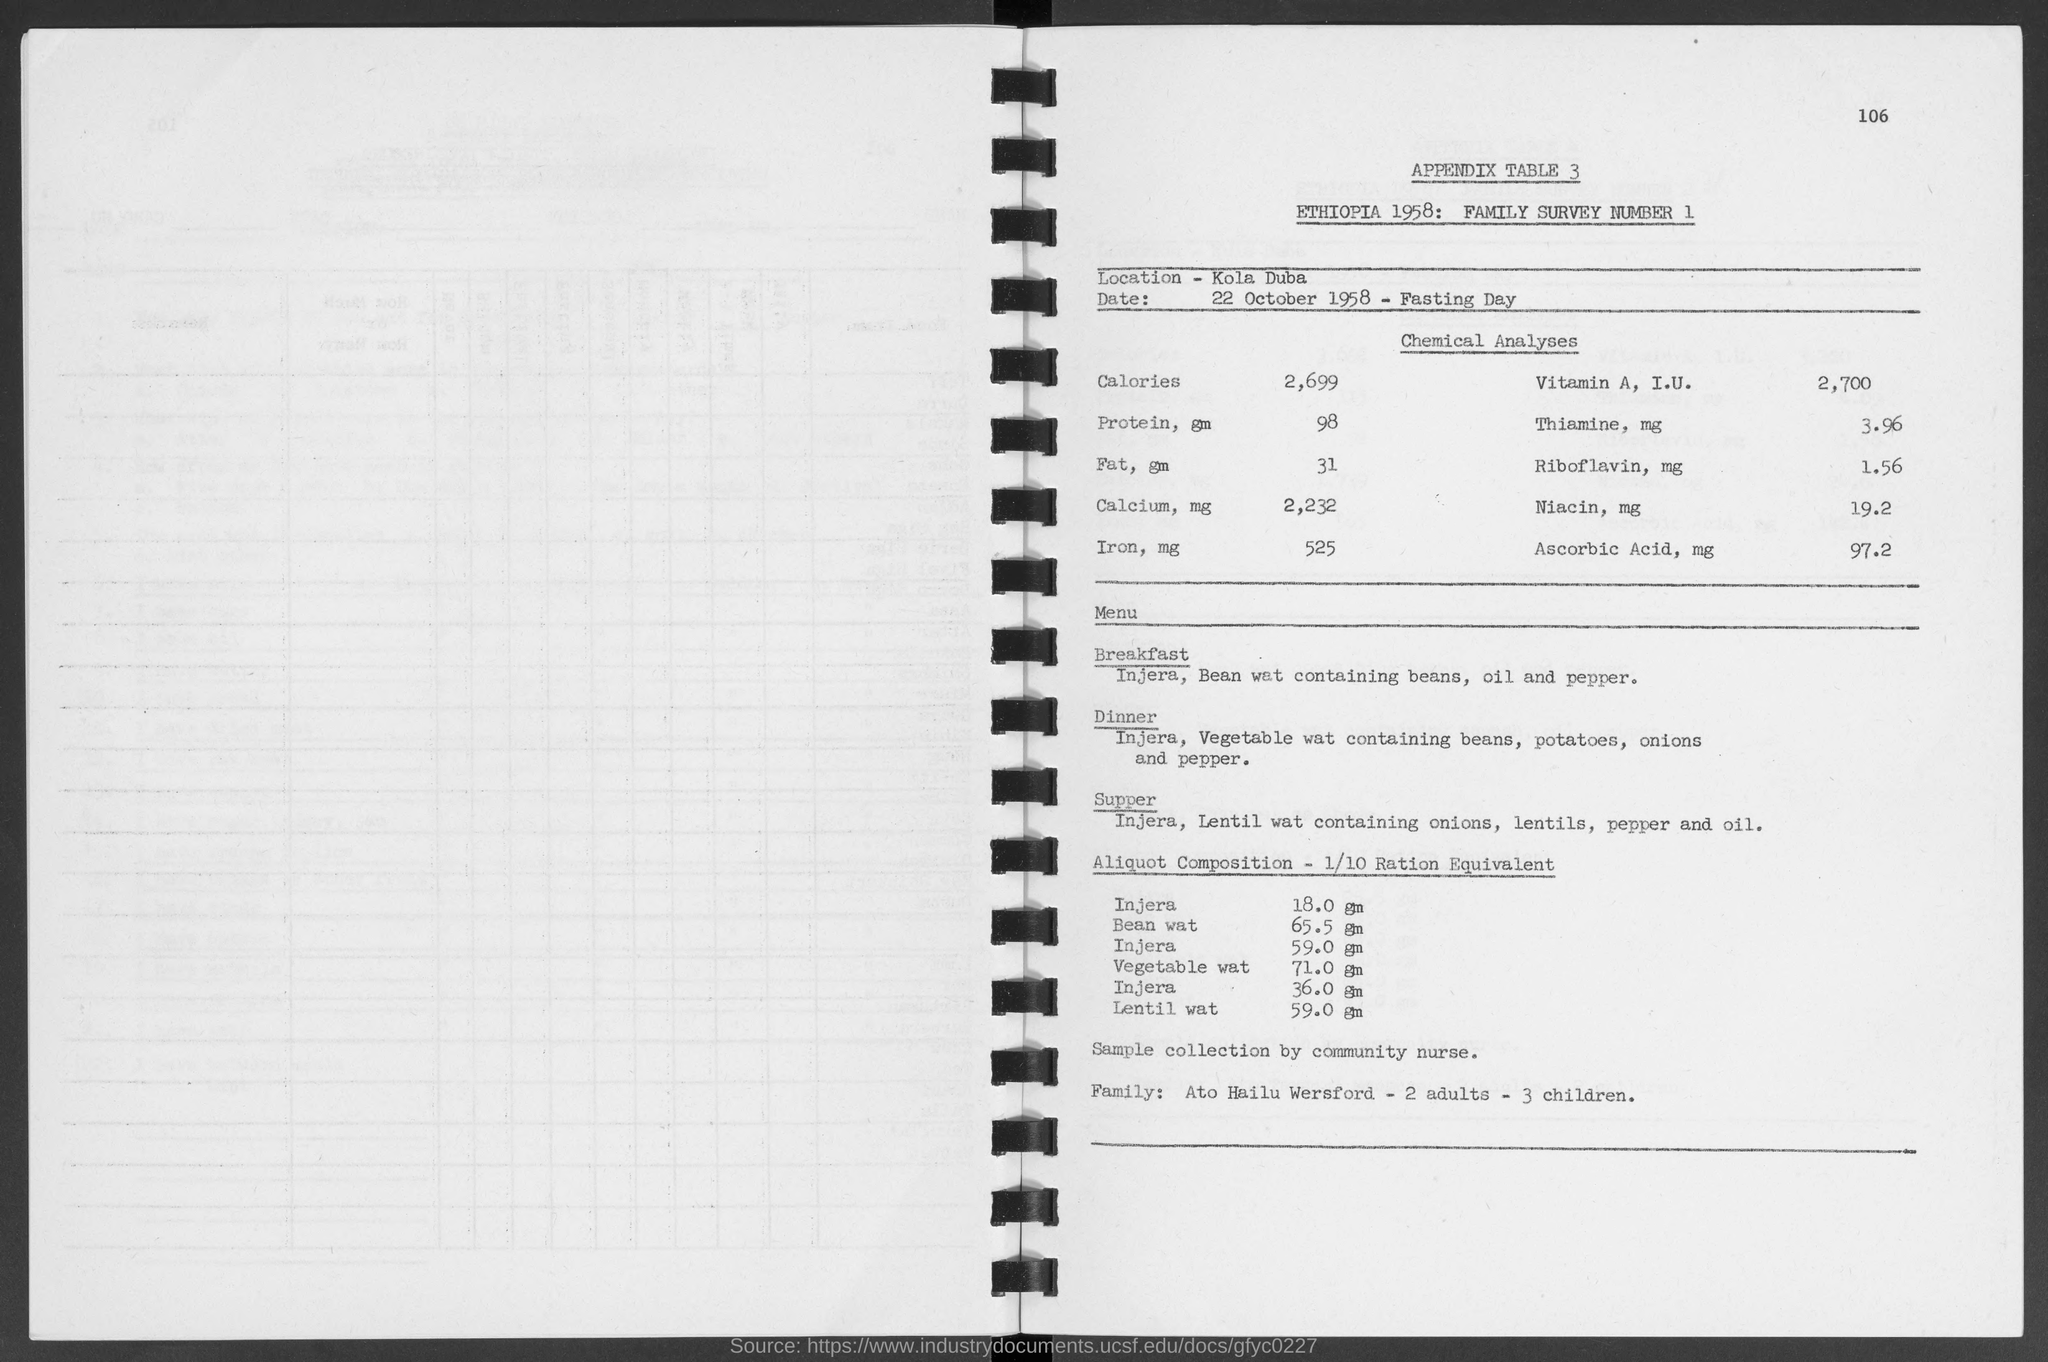Indicate a few pertinent items in this graphic. The amount of Bean water in a 1/10 ratio equivalent is 65.5 grams. The amount of vegetable water in an aliquot composition with a 1/10 ratio equivalent is 71.0 grams. The family survey number is 1. The number at the top-right corner of the page is 106. On October 22nd, 1958, the date was recorded. 